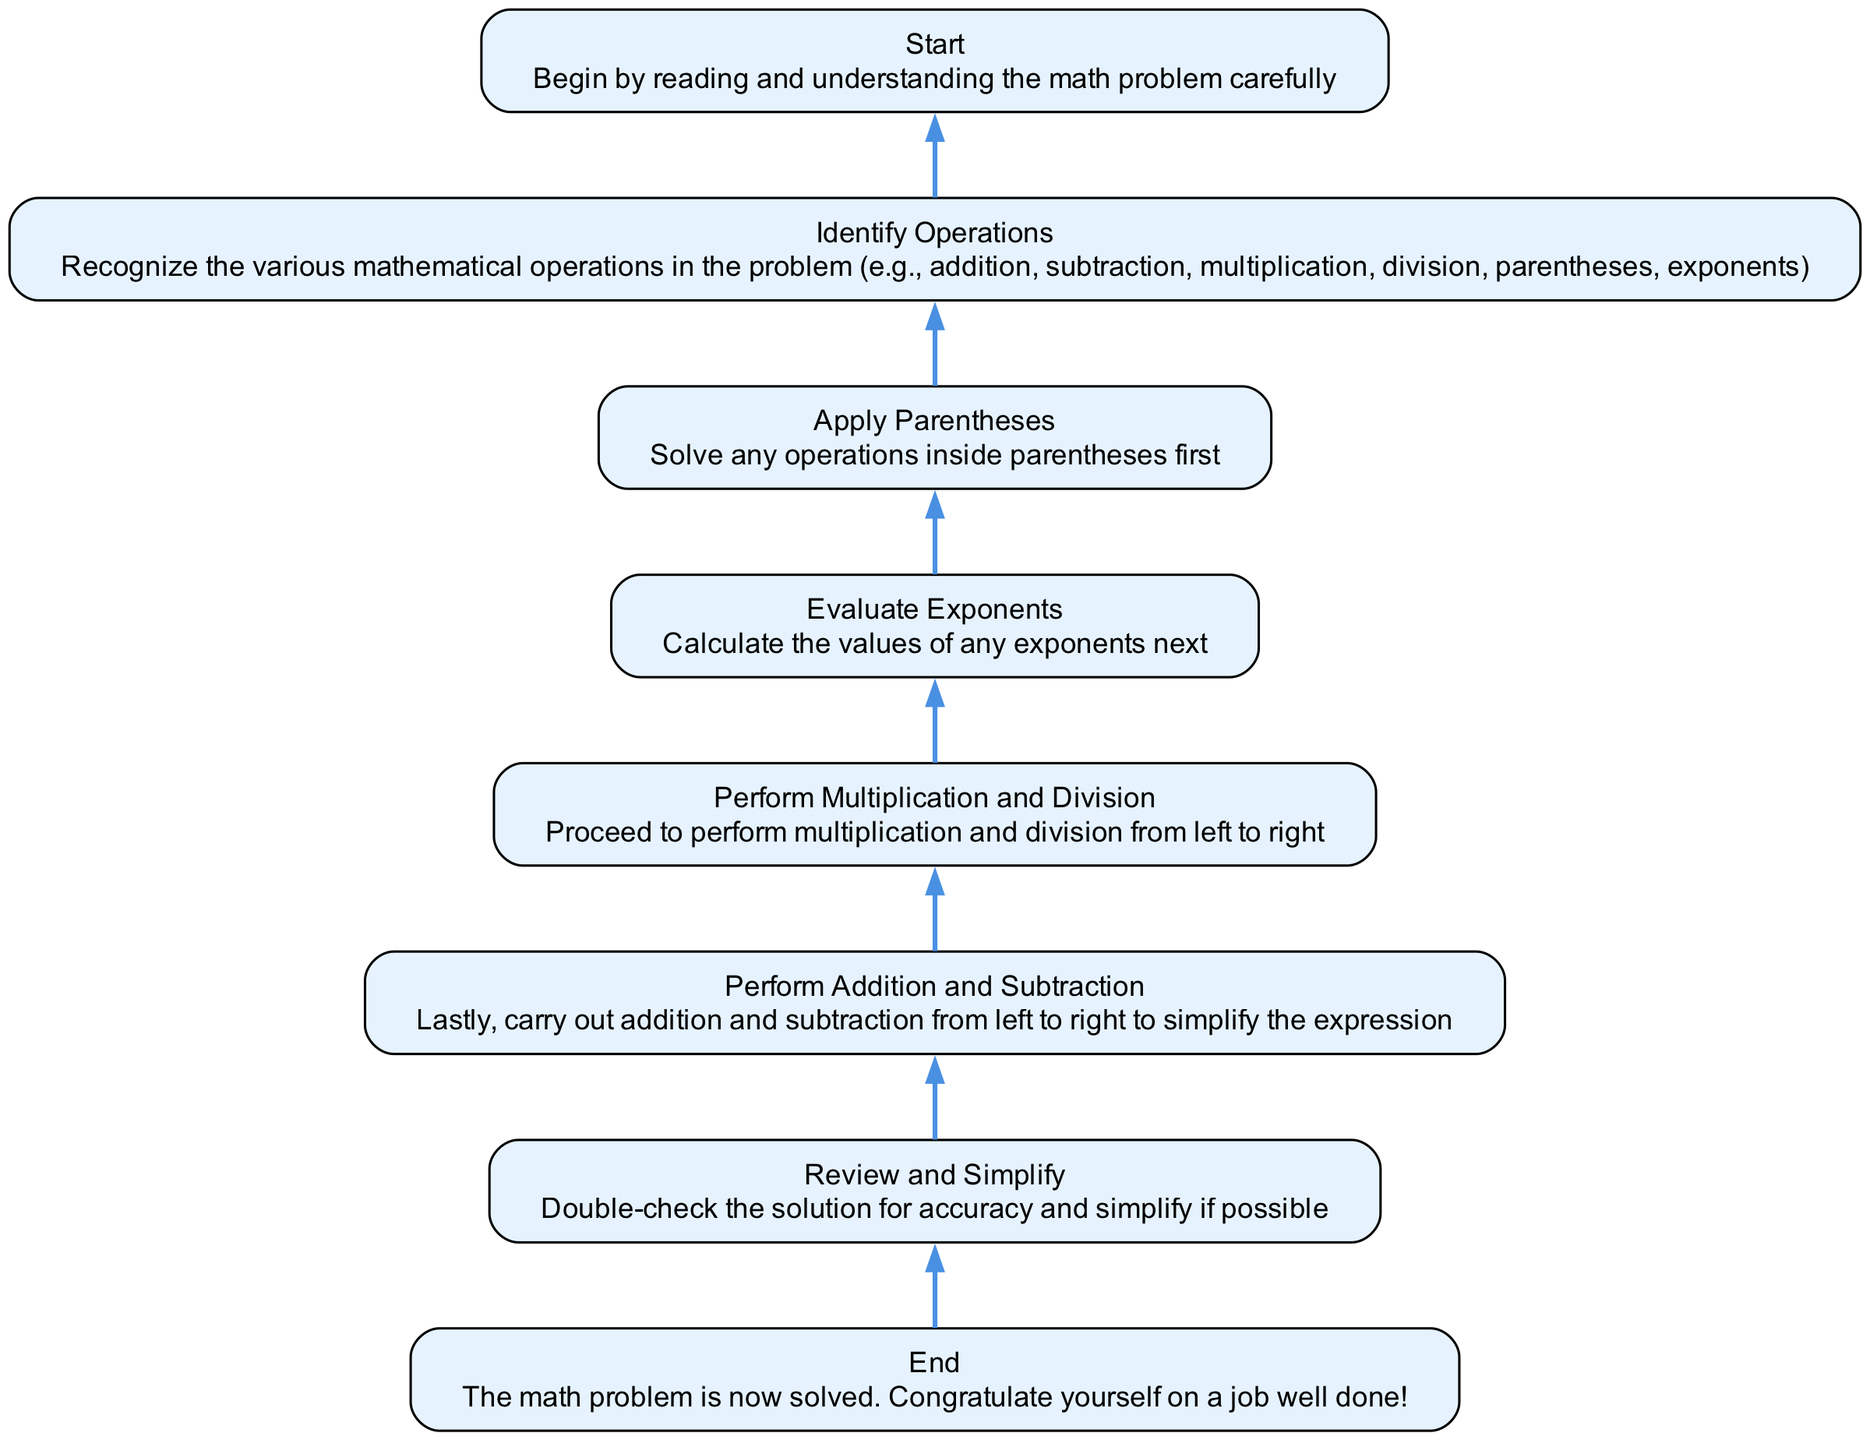What is the first step in solving a math problem according to the flowchart? The first step is "Start," which indicates to read and understand the math problem carefully. This establishes the foundational understanding needed before progressing.
Answer: Start How many nodes are in the diagram? Counting all elements in the flowchart includes "Start," "Identify Operations," "Apply Parentheses," "Evaluate Exponents," "Perform Multiplication and Division," "Perform Addition and Subtraction," "Review and Simplify," and "End." There are a total of eight nodes.
Answer: Eight What is the operation performed after "Apply Parentheses"? Following "Apply Parentheses," the next operation to perform is "Evaluate Exponents." This shows the sequence of operations as per the order of operations rules.
Answer: Evaluate Exponents Which step comes immediately before "End"? The step preceding "End" is "Review and Simplify." This indicates that checking the solution for accuracy is essential before finalizing the answer.
Answer: Review and Simplify What is the relationship between "Perform Multiplication and Division" and "Perform Addition and Subtraction"? "Perform Multiplication and Division" is performed before "Perform Addition and Subtraction." This adheres to the arithmetic rules dictating the order of operations, where multiplication and division take priority over addition and subtraction.
Answer: Before In which direction does the flowchart progress? The flowchart progresses from bottom to top, illustrating the sequence of steps to take when solving a math problem, emphasizing the order of operations.
Answer: Bottom to top Is there any node in the diagram that represents a form of validation or verification? Yes, the "Review and Simplify" node serves as a validation step, as it involves checking for accuracy in the solution and simplifying if possible.
Answer: Review and Simplify Which operation should be tackled immediately after identifying the operations? After identifying the operations, the next step is to "Apply Parentheses," which should be handled first according to the order of operations.
Answer: Apply Parentheses 